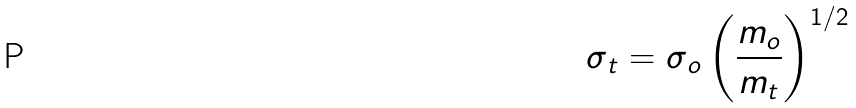<formula> <loc_0><loc_0><loc_500><loc_500>\sigma _ { t } = \sigma _ { o } \left ( \frac { m _ { o } } { m _ { t } } \right ) ^ { 1 / 2 }</formula> 